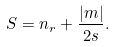Convert formula to latex. <formula><loc_0><loc_0><loc_500><loc_500>S = n _ { r } + \frac { | m | } { 2 s } .</formula> 